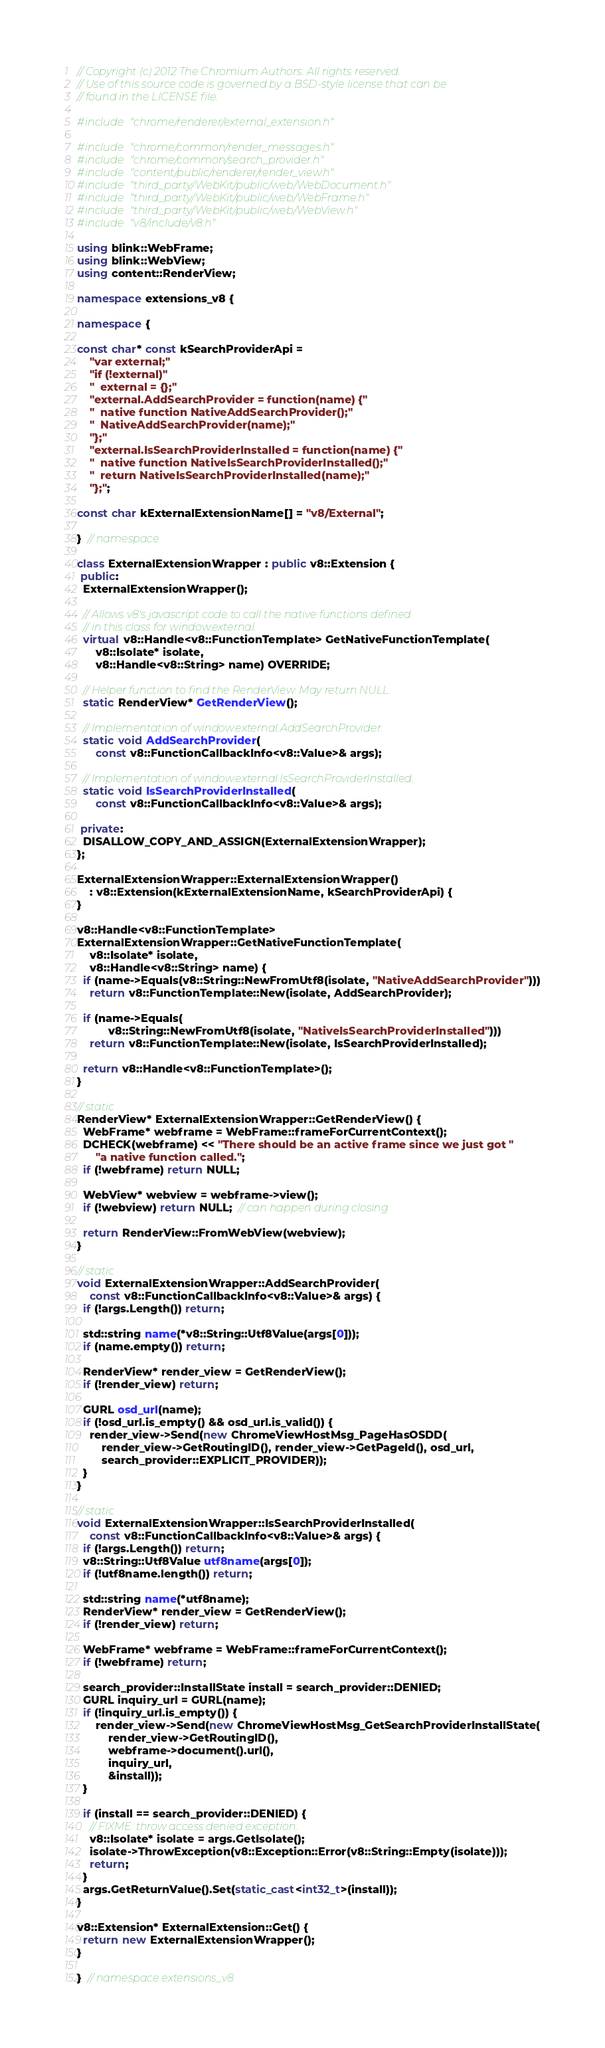Convert code to text. <code><loc_0><loc_0><loc_500><loc_500><_C++_>// Copyright (c) 2012 The Chromium Authors. All rights reserved.
// Use of this source code is governed by a BSD-style license that can be
// found in the LICENSE file.

#include "chrome/renderer/external_extension.h"

#include "chrome/common/render_messages.h"
#include "chrome/common/search_provider.h"
#include "content/public/renderer/render_view.h"
#include "third_party/WebKit/public/web/WebDocument.h"
#include "third_party/WebKit/public/web/WebFrame.h"
#include "third_party/WebKit/public/web/WebView.h"
#include "v8/include/v8.h"

using blink::WebFrame;
using blink::WebView;
using content::RenderView;

namespace extensions_v8 {

namespace {

const char* const kSearchProviderApi =
    "var external;"
    "if (!external)"
    "  external = {};"
    "external.AddSearchProvider = function(name) {"
    "  native function NativeAddSearchProvider();"
    "  NativeAddSearchProvider(name);"
    "};"
    "external.IsSearchProviderInstalled = function(name) {"
    "  native function NativeIsSearchProviderInstalled();"
    "  return NativeIsSearchProviderInstalled(name);"
    "};";

const char kExternalExtensionName[] = "v8/External";

}  // namespace

class ExternalExtensionWrapper : public v8::Extension {
 public:
  ExternalExtensionWrapper();

  // Allows v8's javascript code to call the native functions defined
  // in this class for window.external.
  virtual v8::Handle<v8::FunctionTemplate> GetNativeFunctionTemplate(
      v8::Isolate* isolate,
      v8::Handle<v8::String> name) OVERRIDE;

  // Helper function to find the RenderView. May return NULL.
  static RenderView* GetRenderView();

  // Implementation of window.external.AddSearchProvider.
  static void AddSearchProvider(
      const v8::FunctionCallbackInfo<v8::Value>& args);

  // Implementation of window.external.IsSearchProviderInstalled.
  static void IsSearchProviderInstalled(
      const v8::FunctionCallbackInfo<v8::Value>& args);

 private:
  DISALLOW_COPY_AND_ASSIGN(ExternalExtensionWrapper);
};

ExternalExtensionWrapper::ExternalExtensionWrapper()
    : v8::Extension(kExternalExtensionName, kSearchProviderApi) {
}

v8::Handle<v8::FunctionTemplate>
ExternalExtensionWrapper::GetNativeFunctionTemplate(
    v8::Isolate* isolate,
    v8::Handle<v8::String> name) {
  if (name->Equals(v8::String::NewFromUtf8(isolate, "NativeAddSearchProvider")))
    return v8::FunctionTemplate::New(isolate, AddSearchProvider);

  if (name->Equals(
          v8::String::NewFromUtf8(isolate, "NativeIsSearchProviderInstalled")))
    return v8::FunctionTemplate::New(isolate, IsSearchProviderInstalled);

  return v8::Handle<v8::FunctionTemplate>();
}

// static
RenderView* ExternalExtensionWrapper::GetRenderView() {
  WebFrame* webframe = WebFrame::frameForCurrentContext();
  DCHECK(webframe) << "There should be an active frame since we just got "
      "a native function called.";
  if (!webframe) return NULL;

  WebView* webview = webframe->view();
  if (!webview) return NULL;  // can happen during closing

  return RenderView::FromWebView(webview);
}

// static
void ExternalExtensionWrapper::AddSearchProvider(
    const v8::FunctionCallbackInfo<v8::Value>& args) {
  if (!args.Length()) return;

  std::string name(*v8::String::Utf8Value(args[0]));
  if (name.empty()) return;

  RenderView* render_view = GetRenderView();
  if (!render_view) return;

  GURL osd_url(name);
  if (!osd_url.is_empty() && osd_url.is_valid()) {
    render_view->Send(new ChromeViewHostMsg_PageHasOSDD(
        render_view->GetRoutingID(), render_view->GetPageId(), osd_url,
        search_provider::EXPLICIT_PROVIDER));
  }
}

// static
void ExternalExtensionWrapper::IsSearchProviderInstalled(
    const v8::FunctionCallbackInfo<v8::Value>& args) {
  if (!args.Length()) return;
  v8::String::Utf8Value utf8name(args[0]);
  if (!utf8name.length()) return;

  std::string name(*utf8name);
  RenderView* render_view = GetRenderView();
  if (!render_view) return;

  WebFrame* webframe = WebFrame::frameForCurrentContext();
  if (!webframe) return;

  search_provider::InstallState install = search_provider::DENIED;
  GURL inquiry_url = GURL(name);
  if (!inquiry_url.is_empty()) {
      render_view->Send(new ChromeViewHostMsg_GetSearchProviderInstallState(
          render_view->GetRoutingID(),
          webframe->document().url(),
          inquiry_url,
          &install));
  }

  if (install == search_provider::DENIED) {
    // FIXME: throw access denied exception.
    v8::Isolate* isolate = args.GetIsolate();
    isolate->ThrowException(v8::Exception::Error(v8::String::Empty(isolate)));
    return;
  }
  args.GetReturnValue().Set(static_cast<int32_t>(install));
}

v8::Extension* ExternalExtension::Get() {
  return new ExternalExtensionWrapper();
}

}  // namespace extensions_v8
</code> 